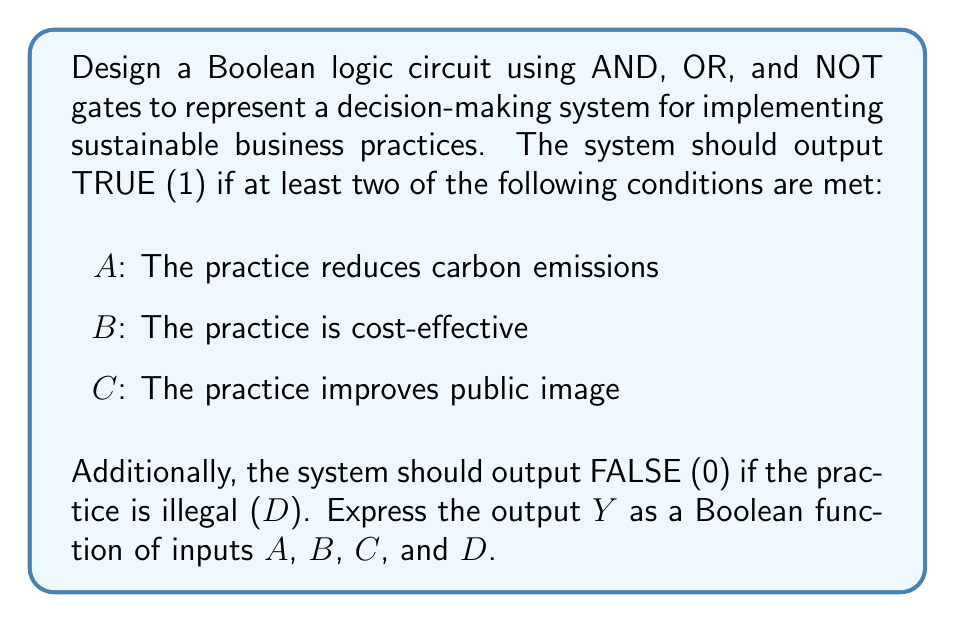Show me your answer to this math problem. Let's approach this step-by-step:

1. First, we need to represent "at least two of A, B, C are true". This can be done using the following expression:
   $$(A \cdot B) + (B \cdot C) + (A \cdot C)$$

2. We then need to ensure that D (illegal practice) overrides everything else. We can do this by ANDing the above expression with NOT D:
   $$((A \cdot B) + (B \cdot C) + (A \cdot C)) \cdot \overline{D}$$

3. Let's simplify this expression:
   $$Y = (AB + BC + AC) \cdot \overline{D}$$

4. This Boolean function can be implemented using the following logic gates:
   - Three AND gates for $AB$, $BC$, and $AC$
   - One OR gate to combine the outputs of these AND gates
   - One NOT gate for $\overline{D}$
   - One final AND gate to combine the result with $\overline{D}$

5. The circuit can be represented as follows:

[asy]
unitsize(1cm);

pair A = (0,4), B = (0,3), C = (0,2), D = (0,0);
pair AND1 = (2,3.5), AND2 = (2,2.5), AND3 = (2,1.5);
pair OR = (4,2.5);
pair NOT = (2,0);
pair ANDL = (6,1.5);

draw(A--AND1--OR);
draw(B--AND1);
draw(B--AND2--OR);
draw(C--AND2);
draw(A--AND3--OR);
draw(C--AND3);
draw(D--NOT--ANDL);
draw(OR--ANDL--(8,1.5));

label("A", A, W);
label("B", B, W);
label("C", C, W);
label("D", D, W);
label("AND", AND1, E);
label("AND", AND2, E);
label("AND", AND3, E);
label("OR", OR, E);
label("NOT", NOT, E);
label("AND", ANDL, E);
label("Y", (8,1.5), E);
[/asy]

This circuit implements the Boolean function $Y = (AB + BC + AC) \cdot \overline{D}$, which satisfies all the given conditions for the sustainable business practice decision-making system.
Answer: $Y = (AB + BC + AC) \cdot \overline{D}$ 